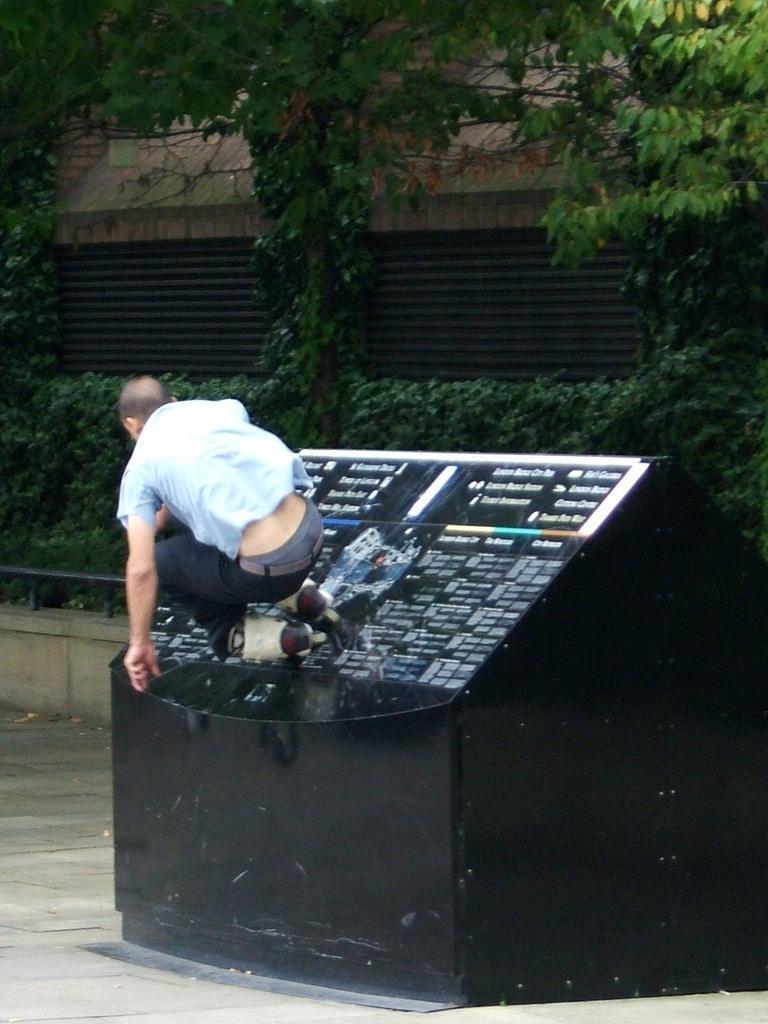Can you describe this image briefly? In this image I can see a man and in the background I can see number of trees and a building. 